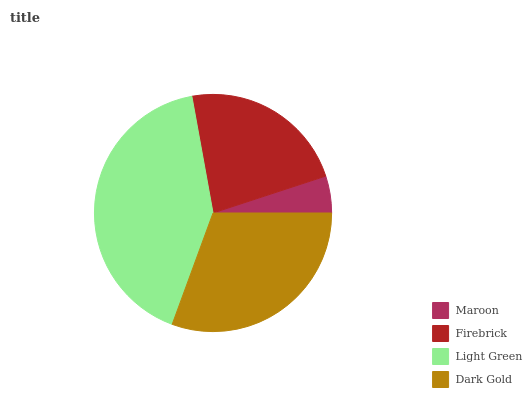Is Maroon the minimum?
Answer yes or no. Yes. Is Light Green the maximum?
Answer yes or no. Yes. Is Firebrick the minimum?
Answer yes or no. No. Is Firebrick the maximum?
Answer yes or no. No. Is Firebrick greater than Maroon?
Answer yes or no. Yes. Is Maroon less than Firebrick?
Answer yes or no. Yes. Is Maroon greater than Firebrick?
Answer yes or no. No. Is Firebrick less than Maroon?
Answer yes or no. No. Is Dark Gold the high median?
Answer yes or no. Yes. Is Firebrick the low median?
Answer yes or no. Yes. Is Maroon the high median?
Answer yes or no. No. Is Light Green the low median?
Answer yes or no. No. 